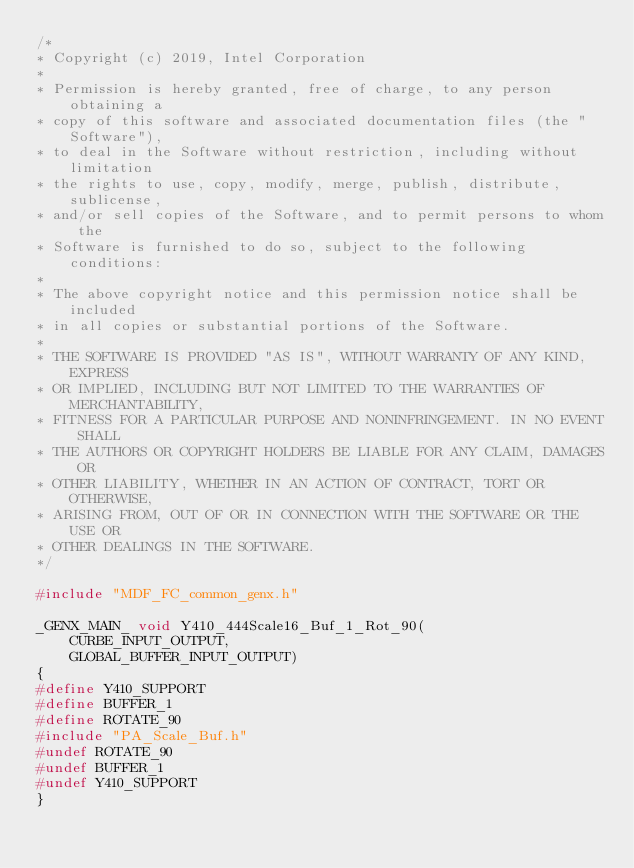Convert code to text. <code><loc_0><loc_0><loc_500><loc_500><_C++_>/*
* Copyright (c) 2019, Intel Corporation
*
* Permission is hereby granted, free of charge, to any person obtaining a
* copy of this software and associated documentation files (the "Software"),
* to deal in the Software without restriction, including without limitation
* the rights to use, copy, modify, merge, publish, distribute, sublicense,
* and/or sell copies of the Software, and to permit persons to whom the
* Software is furnished to do so, subject to the following conditions:
*
* The above copyright notice and this permission notice shall be included
* in all copies or substantial portions of the Software.
*
* THE SOFTWARE IS PROVIDED "AS IS", WITHOUT WARRANTY OF ANY KIND, EXPRESS
* OR IMPLIED, INCLUDING BUT NOT LIMITED TO THE WARRANTIES OF MERCHANTABILITY,
* FITNESS FOR A PARTICULAR PURPOSE AND NONINFRINGEMENT. IN NO EVENT SHALL
* THE AUTHORS OR COPYRIGHT HOLDERS BE LIABLE FOR ANY CLAIM, DAMAGES OR
* OTHER LIABILITY, WHETHER IN AN ACTION OF CONTRACT, TORT OR OTHERWISE,
* ARISING FROM, OUT OF OR IN CONNECTION WITH THE SOFTWARE OR THE USE OR
* OTHER DEALINGS IN THE SOFTWARE.
*/

#include "MDF_FC_common_genx.h"

_GENX_MAIN_ void Y410_444Scale16_Buf_1_Rot_90(
    CURBE_INPUT_OUTPUT,
    GLOBAL_BUFFER_INPUT_OUTPUT)
{
#define Y410_SUPPORT
#define BUFFER_1
#define ROTATE_90
#include "PA_Scale_Buf.h"
#undef ROTATE_90
#undef BUFFER_1
#undef Y410_SUPPORT
}</code> 